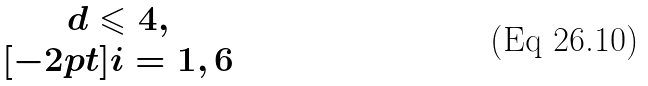Convert formula to latex. <formula><loc_0><loc_0><loc_500><loc_500>\begin{matrix} d \leqslant 4 , \\ [ - 2 p t ] i = 1 , 6 \end{matrix}</formula> 